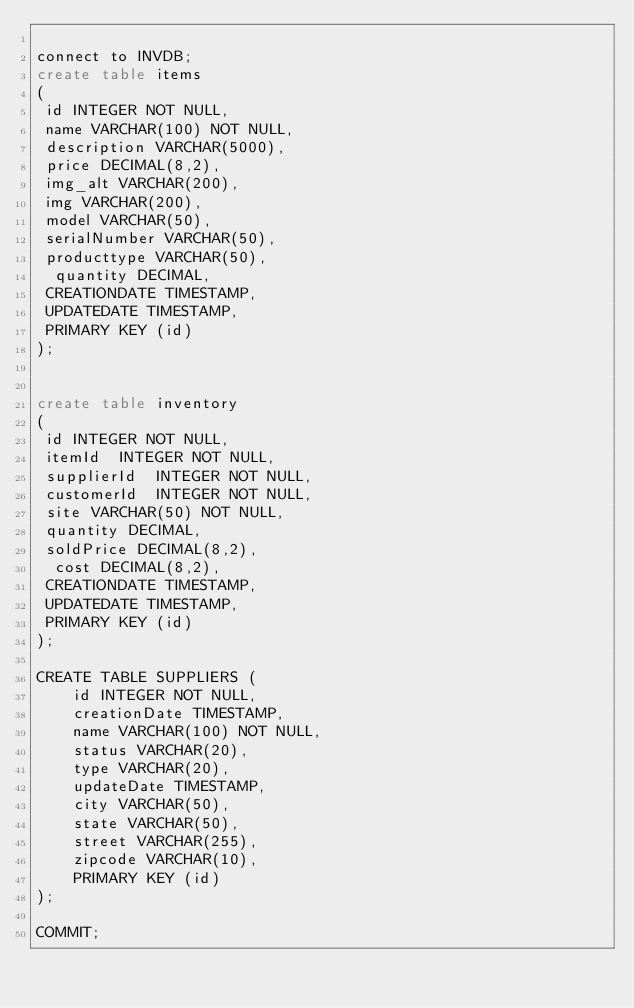<code> <loc_0><loc_0><loc_500><loc_500><_SQL_>
connect to INVDB;
create table items
(
 id INTEGER NOT NULL,
 name VARCHAR(100) NOT NULL,
 description VARCHAR(5000),
 price DECIMAL(8,2),
 img_alt VARCHAR(200),
 img VARCHAR(200),
 model VARCHAR(50),
 serialNumber VARCHAR(50),
 producttype VARCHAR(50),
  quantity DECIMAL,
 CREATIONDATE TIMESTAMP,
 UPDATEDATE TIMESTAMP,
 PRIMARY KEY (id)
);


create table inventory
(
 id INTEGER NOT NULL, 
 itemId  INTEGER NOT NULL, 
 supplierId  INTEGER NOT NULL, 
 customerId  INTEGER NOT NULL, 
 site VARCHAR(50) NOT NULL, 
 quantity DECIMAL,
 soldPrice DECIMAL(8,2),
  cost DECIMAL(8,2),
 CREATIONDATE TIMESTAMP,
 UPDATEDATE TIMESTAMP,
 PRIMARY KEY (id)
);

CREATE TABLE SUPPLIERS (
 	id INTEGER NOT NULL, 
 	creationDate TIMESTAMP, 
 	name VARCHAR(100) NOT NULL, 
 	status VARCHAR(20), 
 	type VARCHAR(20),
 	updateDate TIMESTAMP, 
 	city VARCHAR(50), 
 	state VARCHAR(50),
    street VARCHAR(255), 
    zipcode VARCHAR(10), 
    PRIMARY KEY (id)
);

COMMIT;
</code> 